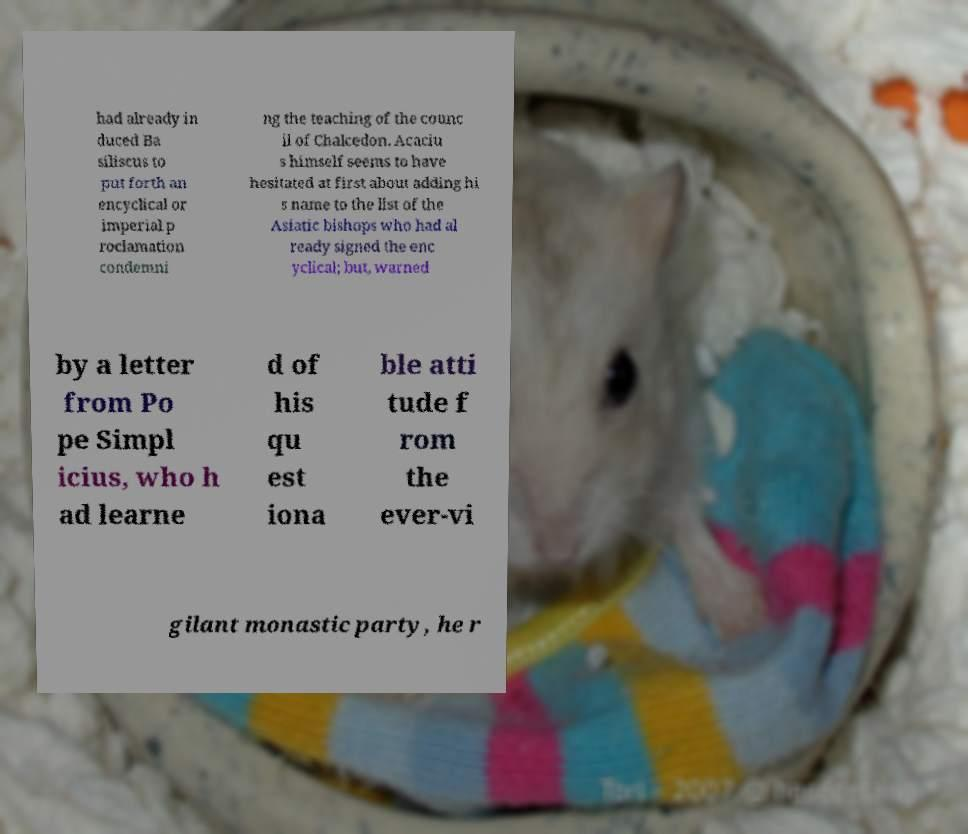Can you accurately transcribe the text from the provided image for me? had already in duced Ba siliscus to put forth an encyclical or imperial p roclamation condemni ng the teaching of the counc il of Chalcedon. Acaciu s himself seems to have hesitated at first about adding hi s name to the list of the Asiatic bishops who had al ready signed the enc yclical; but, warned by a letter from Po pe Simpl icius, who h ad learne d of his qu est iona ble atti tude f rom the ever-vi gilant monastic party, he r 